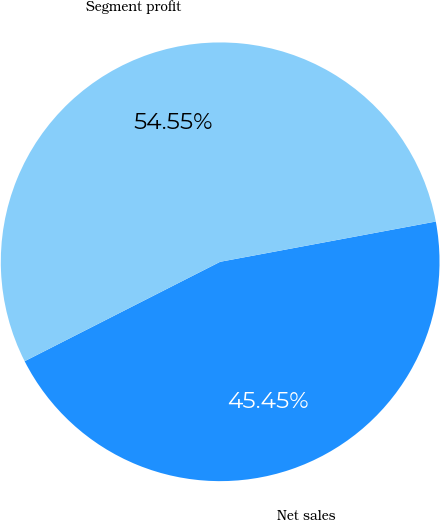Convert chart. <chart><loc_0><loc_0><loc_500><loc_500><pie_chart><fcel>Net sales<fcel>Segment profit<nl><fcel>45.45%<fcel>54.55%<nl></chart> 